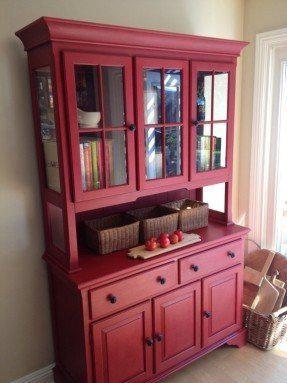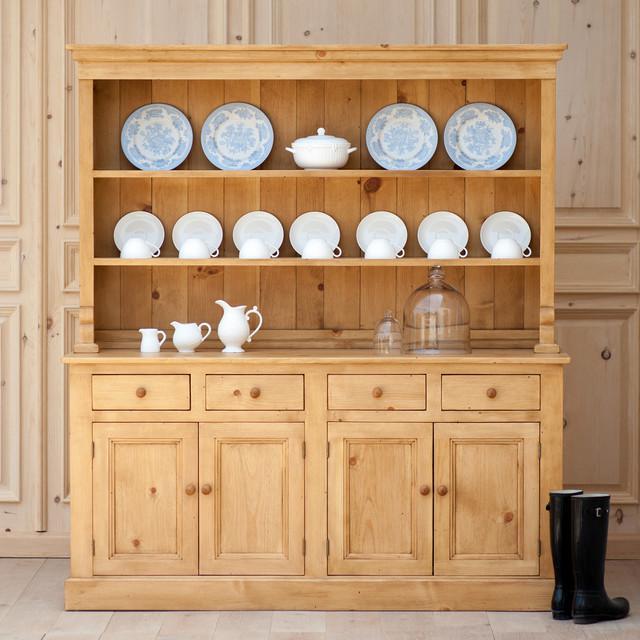The first image is the image on the left, the second image is the image on the right. For the images displayed, is the sentence "One of these images contains a completely empty hutch, and all of these images are on a plain white background." factually correct? Answer yes or no. No. The first image is the image on the left, the second image is the image on the right. For the images displayed, is the sentence "Brown cabinets are on a stark white background" factually correct? Answer yes or no. No. 